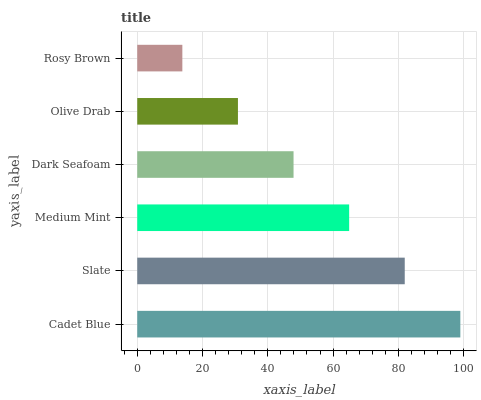Is Rosy Brown the minimum?
Answer yes or no. Yes. Is Cadet Blue the maximum?
Answer yes or no. Yes. Is Slate the minimum?
Answer yes or no. No. Is Slate the maximum?
Answer yes or no. No. Is Cadet Blue greater than Slate?
Answer yes or no. Yes. Is Slate less than Cadet Blue?
Answer yes or no. Yes. Is Slate greater than Cadet Blue?
Answer yes or no. No. Is Cadet Blue less than Slate?
Answer yes or no. No. Is Medium Mint the high median?
Answer yes or no. Yes. Is Dark Seafoam the low median?
Answer yes or no. Yes. Is Cadet Blue the high median?
Answer yes or no. No. Is Olive Drab the low median?
Answer yes or no. No. 